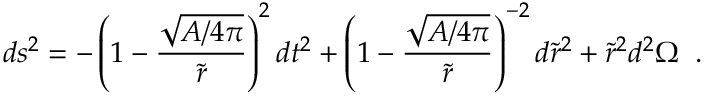Convert formula to latex. <formula><loc_0><loc_0><loc_500><loc_500>d s ^ { 2 } = - \left ( 1 - { \frac { \sqrt { A / 4 \pi } } { \tilde { r } } } \right ) ^ { 2 } d t ^ { 2 } + \left ( 1 - { \frac { \sqrt { A / 4 \pi } } { \tilde { r } } } \right ) ^ { - 2 } d \tilde { r } ^ { 2 } + \tilde { r } ^ { 2 } d ^ { 2 } \Omega \, .</formula> 